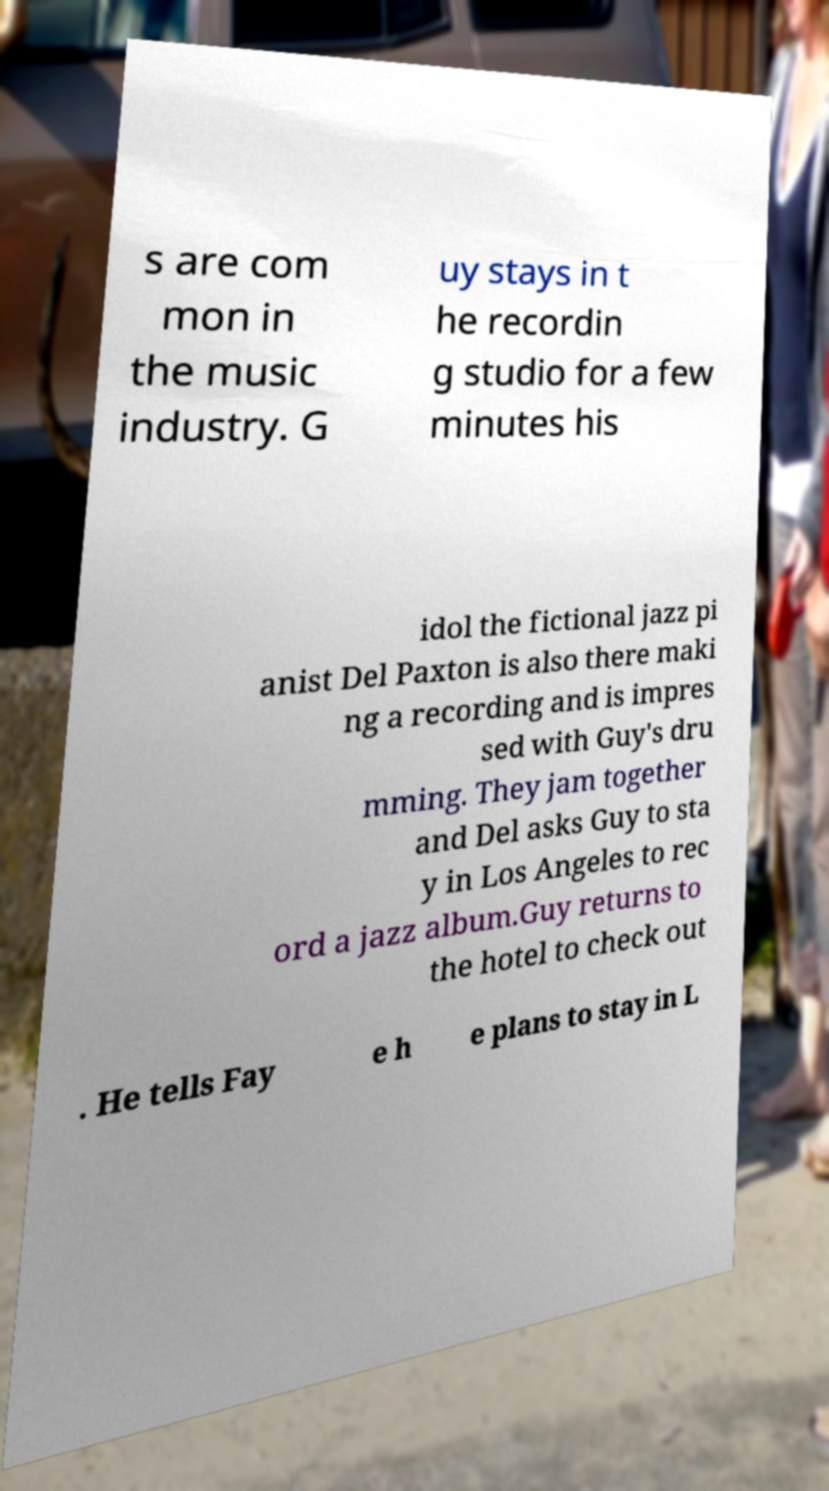Please read and relay the text visible in this image. What does it say? s are com mon in the music industry. G uy stays in t he recordin g studio for a few minutes his idol the fictional jazz pi anist Del Paxton is also there maki ng a recording and is impres sed with Guy's dru mming. They jam together and Del asks Guy to sta y in Los Angeles to rec ord a jazz album.Guy returns to the hotel to check out . He tells Fay e h e plans to stay in L 